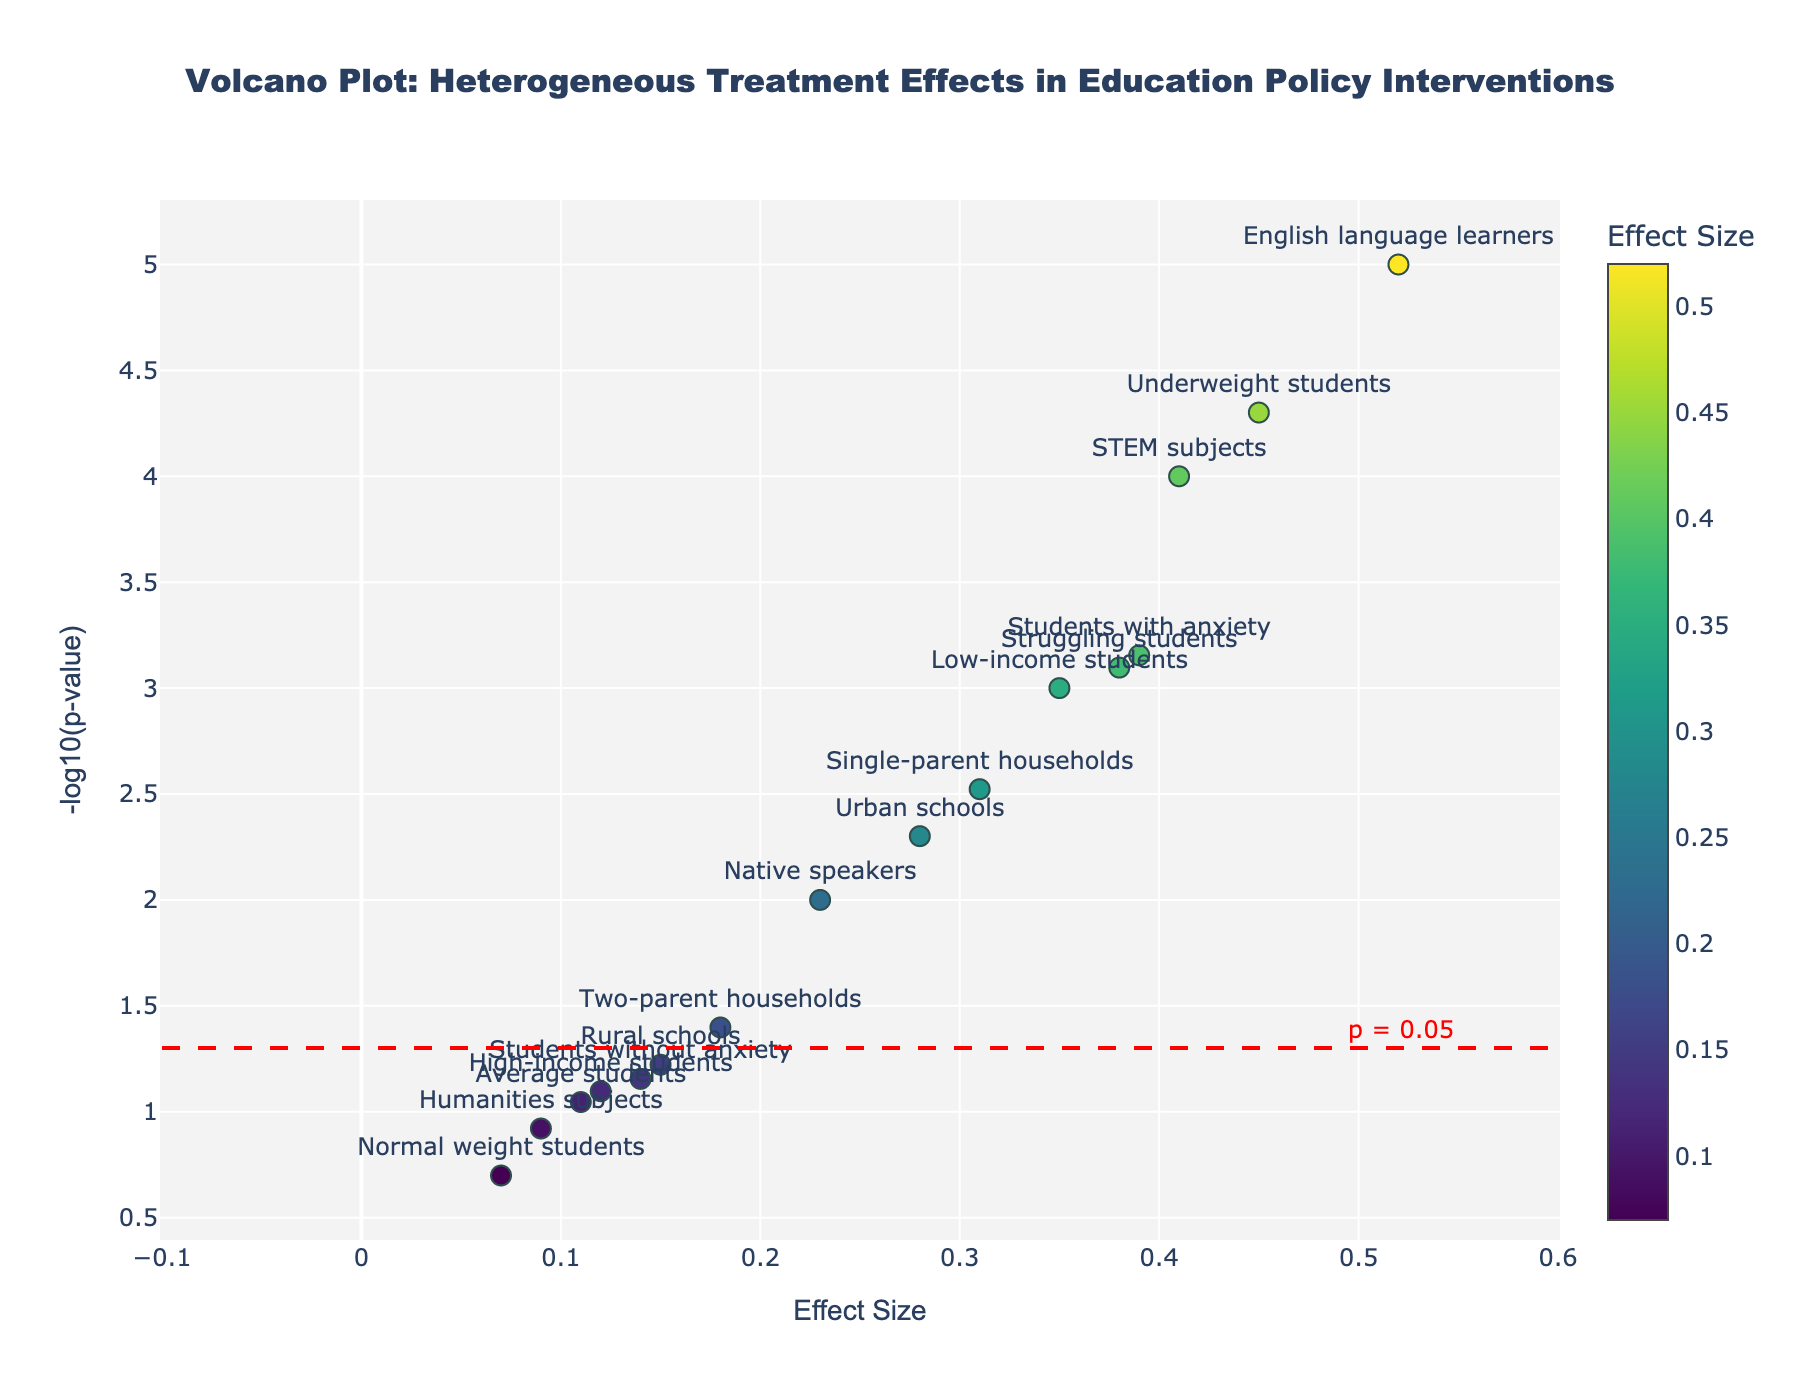What is the title of the plot? The title of the plot is prominently displayed at the top center of the figure and usually provides a description of the overall theme or subject matter of the plot.
Answer: Volcano Plot: Heterogeneous Treatment Effects in Education Policy Interventions What is the range of effect sizes shown on the x-axis? By examining the horizontal x-axis, we can see that it ranges from approximately -0.1 to 0.6.
Answer: -0.1 to 0.6 Which intervention had the highest effect size? Look at the scatter points on the plot and identify the point that appears furthest to the right on the x-axis. The highlighted effect size hovering over this point shows the intervention detail for confirmation.
Answer: Technology integration (STEM subjects) What is the p-value threshold line represented in the plot? There is a horizontal dashed red line representing the significance threshold. The accompanying annotation text near the line helps identify the exact value.
Answer: 0.05 How many interventions have a p-value less than 0.05? Points above the -log10(p-value) of -log10(0.05) indicate p-values less than 0.05. Counting the number of points above this red horizontal line gives the answer.
Answer: 10 Which subgroup benefited the most from early childhood education intervention in terms of effect size? Locate the labels for the "Early childhood education" intervention on the plot and compare their horizontal positions (effect sizes). The subgroup further to the right has the higher effect size.
Answer: English language learners Among the points with p-values less than 0.05, which intervention has the smallest effect size? Identify points above the red p-value threshold line. Compare the x-axis positions for these points to find the one closest to the left side.
Answer: Parental involvement program (Two-parent households) For which intervention and subgroup combination is the effect size and -log10(p-value) both the highest? Locate the highest point on the y-axis (-log10(p-value)) and check its corresponding x-axis position (effect size). Hover text reveals intervention and subgroup details for confirmation.
Answer: Early childhood education (English language learners) What is the color scale used in the plot, and what does it represent? Examine the color gradient beside the plot. It often corresponds to another variable, indicated by a colorbar title. Here the shading suggests it is associated with the effect sizes.
Answer: Viridis, representing Effect Size Which intervention and subgroup has the smallest effect size with a significant p-value? Filter for points above the red threshold line (p < 0.05). Then find the point furthest to the left (smallest effect size) and check the hover text for details.
Answer: Parental involvement program (Two-parent households) 